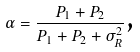Convert formula to latex. <formula><loc_0><loc_0><loc_500><loc_500>\alpha = \frac { P _ { 1 } + P _ { 2 } } { P _ { 1 } + P _ { 2 } + \sigma _ { R } ^ { 2 } } \text  ,</formula> 